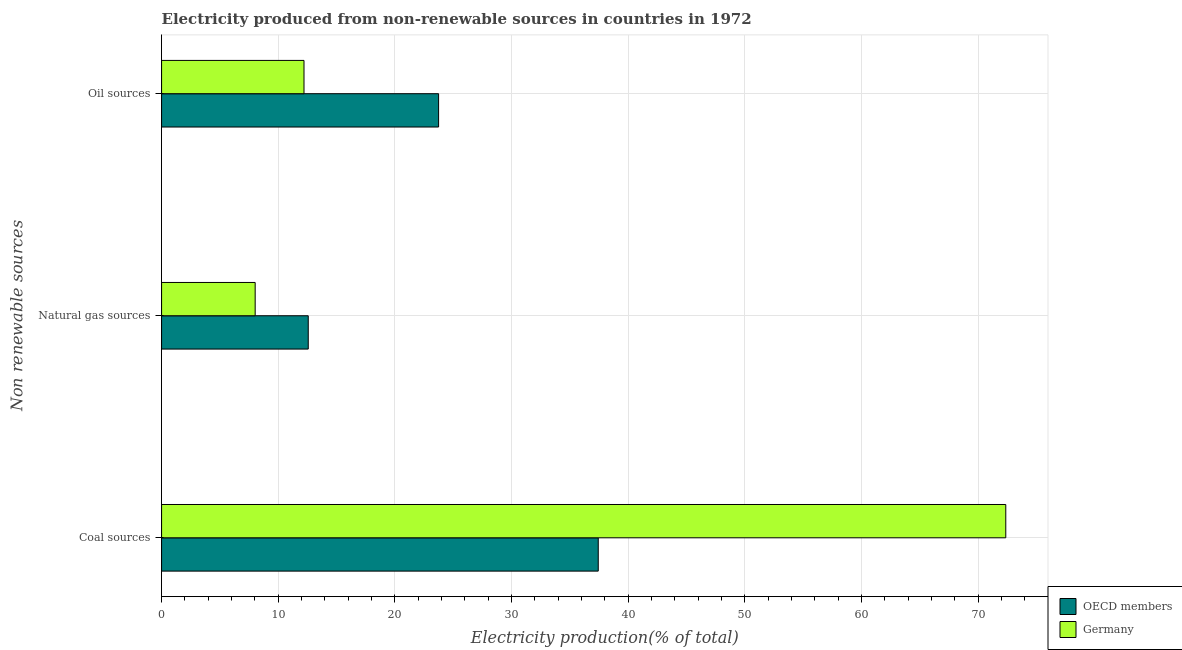How many different coloured bars are there?
Your response must be concise. 2. How many bars are there on the 2nd tick from the top?
Ensure brevity in your answer.  2. What is the label of the 2nd group of bars from the top?
Your response must be concise. Natural gas sources. What is the percentage of electricity produced by coal in OECD members?
Provide a succinct answer. 37.44. Across all countries, what is the maximum percentage of electricity produced by natural gas?
Give a very brief answer. 12.57. Across all countries, what is the minimum percentage of electricity produced by coal?
Offer a very short reply. 37.44. In which country was the percentage of electricity produced by coal maximum?
Your response must be concise. Germany. What is the total percentage of electricity produced by coal in the graph?
Ensure brevity in your answer.  109.82. What is the difference between the percentage of electricity produced by oil sources in Germany and that in OECD members?
Provide a succinct answer. -11.54. What is the difference between the percentage of electricity produced by natural gas in OECD members and the percentage of electricity produced by oil sources in Germany?
Give a very brief answer. 0.36. What is the average percentage of electricity produced by natural gas per country?
Offer a very short reply. 10.3. What is the difference between the percentage of electricity produced by oil sources and percentage of electricity produced by coal in Germany?
Offer a very short reply. -60.17. What is the ratio of the percentage of electricity produced by coal in Germany to that in OECD members?
Provide a short and direct response. 1.93. Is the percentage of electricity produced by natural gas in OECD members less than that in Germany?
Your answer should be compact. No. What is the difference between the highest and the second highest percentage of electricity produced by coal?
Keep it short and to the point. 34.94. What is the difference between the highest and the lowest percentage of electricity produced by oil sources?
Offer a very short reply. 11.54. In how many countries, is the percentage of electricity produced by oil sources greater than the average percentage of electricity produced by oil sources taken over all countries?
Make the answer very short. 1. Is the sum of the percentage of electricity produced by coal in OECD members and Germany greater than the maximum percentage of electricity produced by oil sources across all countries?
Your answer should be compact. Yes. Is it the case that in every country, the sum of the percentage of electricity produced by coal and percentage of electricity produced by natural gas is greater than the percentage of electricity produced by oil sources?
Keep it short and to the point. Yes. How many bars are there?
Offer a very short reply. 6. Are all the bars in the graph horizontal?
Provide a succinct answer. Yes. What is the difference between two consecutive major ticks on the X-axis?
Offer a terse response. 10. Are the values on the major ticks of X-axis written in scientific E-notation?
Provide a short and direct response. No. Where does the legend appear in the graph?
Ensure brevity in your answer.  Bottom right. How many legend labels are there?
Provide a short and direct response. 2. How are the legend labels stacked?
Keep it short and to the point. Vertical. What is the title of the graph?
Offer a terse response. Electricity produced from non-renewable sources in countries in 1972. What is the label or title of the X-axis?
Provide a short and direct response. Electricity production(% of total). What is the label or title of the Y-axis?
Your answer should be very brief. Non renewable sources. What is the Electricity production(% of total) of OECD members in Coal sources?
Make the answer very short. 37.44. What is the Electricity production(% of total) in Germany in Coal sources?
Your response must be concise. 72.38. What is the Electricity production(% of total) of OECD members in Natural gas sources?
Provide a short and direct response. 12.57. What is the Electricity production(% of total) of Germany in Natural gas sources?
Offer a terse response. 8.03. What is the Electricity production(% of total) of OECD members in Oil sources?
Offer a very short reply. 23.75. What is the Electricity production(% of total) in Germany in Oil sources?
Your response must be concise. 12.21. Across all Non renewable sources, what is the maximum Electricity production(% of total) in OECD members?
Give a very brief answer. 37.44. Across all Non renewable sources, what is the maximum Electricity production(% of total) of Germany?
Provide a short and direct response. 72.38. Across all Non renewable sources, what is the minimum Electricity production(% of total) in OECD members?
Your answer should be very brief. 12.57. Across all Non renewable sources, what is the minimum Electricity production(% of total) in Germany?
Offer a very short reply. 8.03. What is the total Electricity production(% of total) in OECD members in the graph?
Your answer should be compact. 73.77. What is the total Electricity production(% of total) of Germany in the graph?
Your answer should be very brief. 92.62. What is the difference between the Electricity production(% of total) in OECD members in Coal sources and that in Natural gas sources?
Keep it short and to the point. 24.86. What is the difference between the Electricity production(% of total) of Germany in Coal sources and that in Natural gas sources?
Make the answer very short. 64.35. What is the difference between the Electricity production(% of total) of OECD members in Coal sources and that in Oil sources?
Provide a succinct answer. 13.69. What is the difference between the Electricity production(% of total) of Germany in Coal sources and that in Oil sources?
Your answer should be compact. 60.17. What is the difference between the Electricity production(% of total) in OECD members in Natural gas sources and that in Oil sources?
Provide a short and direct response. -11.18. What is the difference between the Electricity production(% of total) in Germany in Natural gas sources and that in Oil sources?
Provide a short and direct response. -4.19. What is the difference between the Electricity production(% of total) in OECD members in Coal sources and the Electricity production(% of total) in Germany in Natural gas sources?
Your answer should be very brief. 29.41. What is the difference between the Electricity production(% of total) in OECD members in Coal sources and the Electricity production(% of total) in Germany in Oil sources?
Ensure brevity in your answer.  25.23. What is the difference between the Electricity production(% of total) of OECD members in Natural gas sources and the Electricity production(% of total) of Germany in Oil sources?
Offer a very short reply. 0.36. What is the average Electricity production(% of total) of OECD members per Non renewable sources?
Your answer should be compact. 24.59. What is the average Electricity production(% of total) in Germany per Non renewable sources?
Your answer should be compact. 30.87. What is the difference between the Electricity production(% of total) of OECD members and Electricity production(% of total) of Germany in Coal sources?
Your response must be concise. -34.94. What is the difference between the Electricity production(% of total) of OECD members and Electricity production(% of total) of Germany in Natural gas sources?
Your response must be concise. 4.55. What is the difference between the Electricity production(% of total) of OECD members and Electricity production(% of total) of Germany in Oil sources?
Provide a short and direct response. 11.54. What is the ratio of the Electricity production(% of total) in OECD members in Coal sources to that in Natural gas sources?
Your answer should be very brief. 2.98. What is the ratio of the Electricity production(% of total) in Germany in Coal sources to that in Natural gas sources?
Make the answer very short. 9.02. What is the ratio of the Electricity production(% of total) in OECD members in Coal sources to that in Oil sources?
Your response must be concise. 1.58. What is the ratio of the Electricity production(% of total) of Germany in Coal sources to that in Oil sources?
Make the answer very short. 5.93. What is the ratio of the Electricity production(% of total) in OECD members in Natural gas sources to that in Oil sources?
Ensure brevity in your answer.  0.53. What is the ratio of the Electricity production(% of total) in Germany in Natural gas sources to that in Oil sources?
Make the answer very short. 0.66. What is the difference between the highest and the second highest Electricity production(% of total) of OECD members?
Ensure brevity in your answer.  13.69. What is the difference between the highest and the second highest Electricity production(% of total) of Germany?
Offer a very short reply. 60.17. What is the difference between the highest and the lowest Electricity production(% of total) of OECD members?
Offer a terse response. 24.86. What is the difference between the highest and the lowest Electricity production(% of total) of Germany?
Your response must be concise. 64.35. 